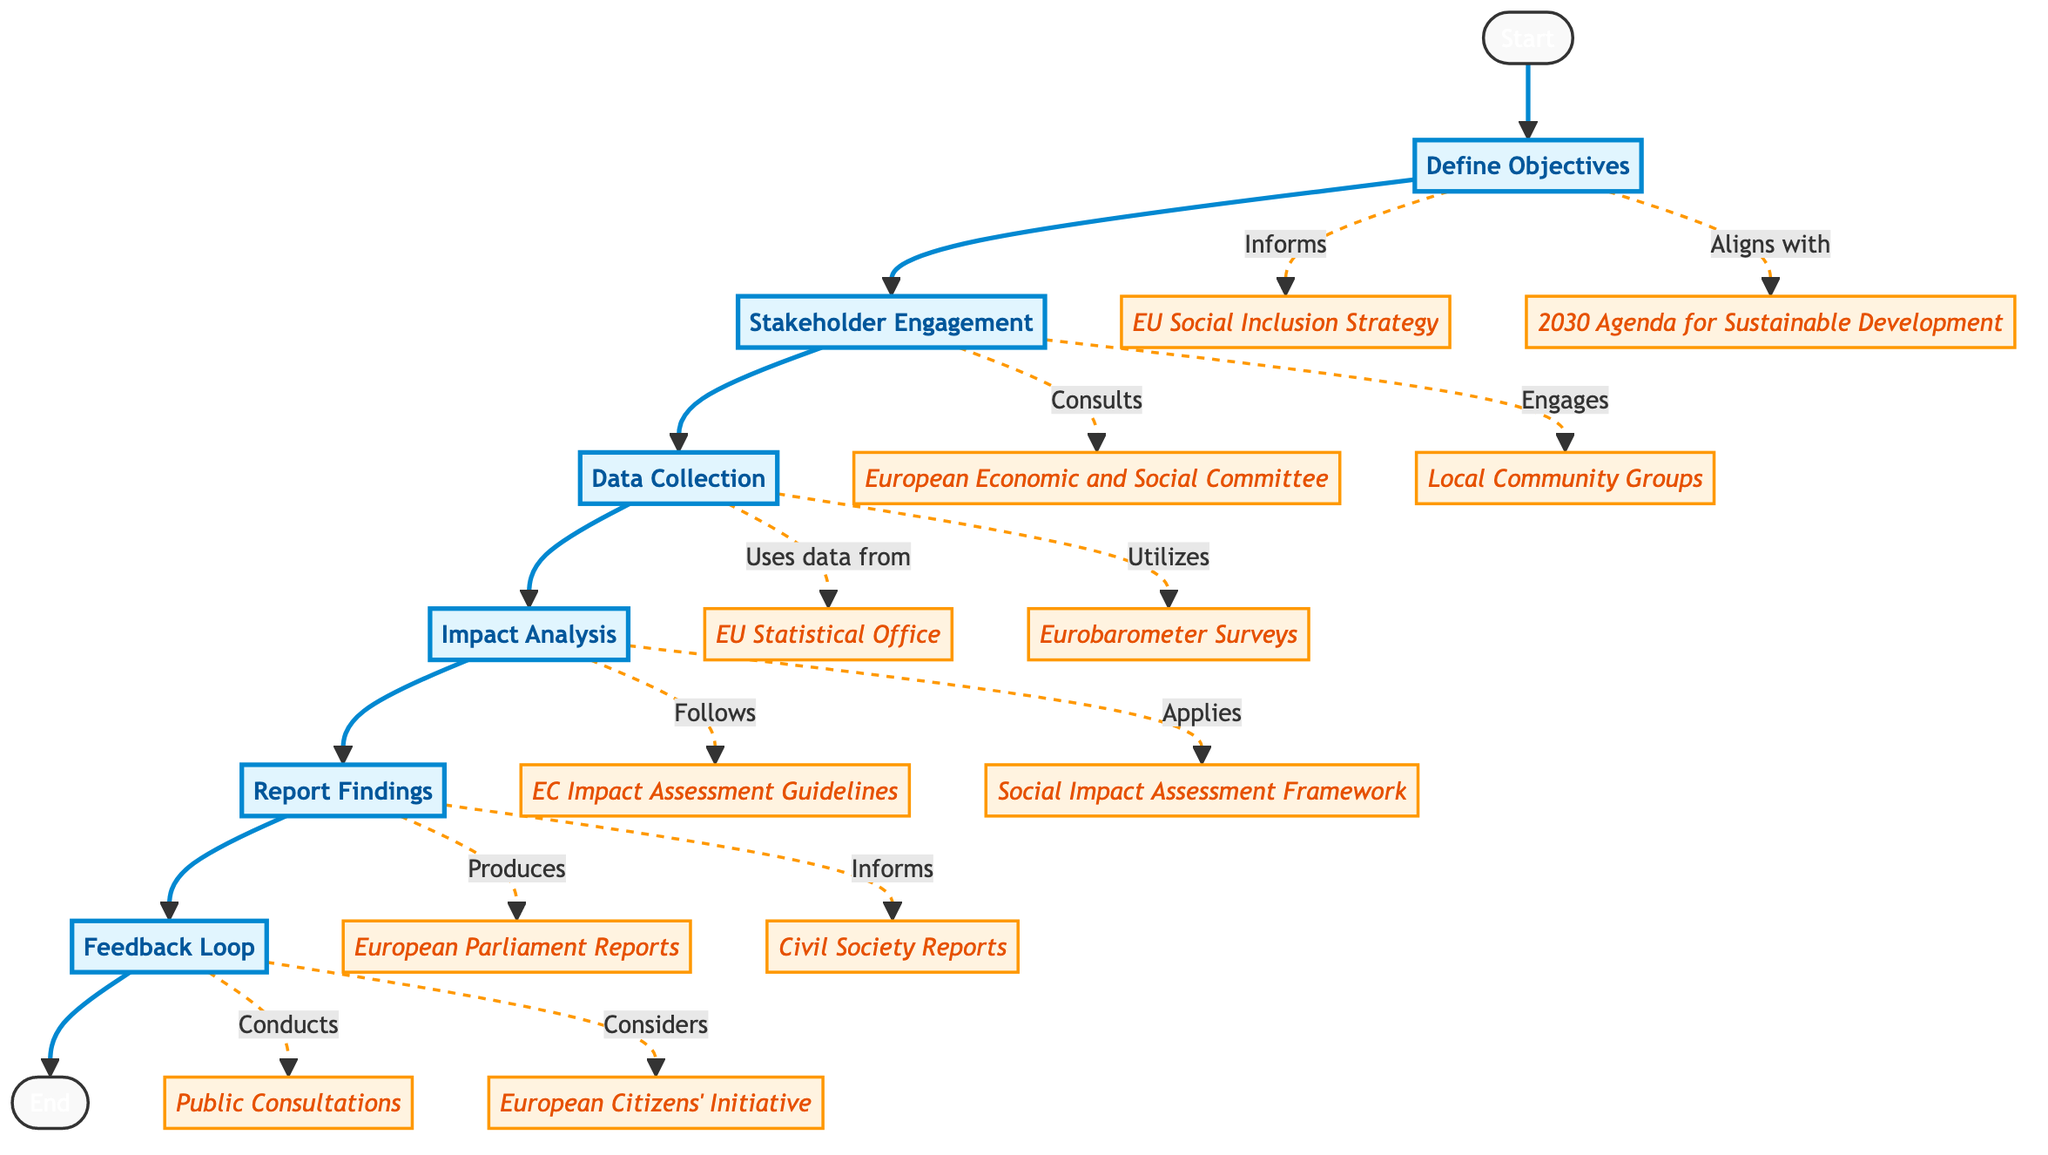What is the first step in the impact assessment process? The first step in the flow chart is "Define Objectives," which establishes clear goals for the social inclusion program.
Answer: Define Objectives How many main steps are there in the impact assessment flow chart? The flow chart consists of six main steps sequentially arranged from start to end.
Answer: Six Which step follows "Data Collection"? After "Data Collection," the next step depicted in the flow chart is "Impact Analysis."
Answer: Impact Analysis What do the stakeholders engage with in the second step? In the second step, stakeholders engage with "Local Community Groups" as part of the engagement process.
Answer: Local Community Groups What type of data is gathered in "Data Collection"? The "Data Collection" step gathers both quantitative and qualitative data on social inclusion.
Answer: Quantitative and Qualitative Which guidelines does the "Impact Analysis" follow? The "Impact Analysis" follows the "European Commission Impact Assessment Guidelines" as indicated in the flow chart.
Answer: European Commission Impact Assessment Guidelines What is the purpose of the "Feedback Loop"? The "Feedback Loop" aims to incorporate feedback to refine and improve the social inclusion program.
Answer: Refine and improve What are two entities consulted during the "Stakeholder Engagement"? Two entities consulted during this step are the "European Economic and Social Committee" and "Local Community Groups."
Answer: European Economic and Social Committee; Local Community Groups How does the "Impact Analysis" relate to the "Report Findings"? The "Impact Analysis" is conducted to measure the program's effects, which informs the subsequent step "Report Findings" that documents the analysis and outcomes.
Answer: Measures effects to inform reporting 